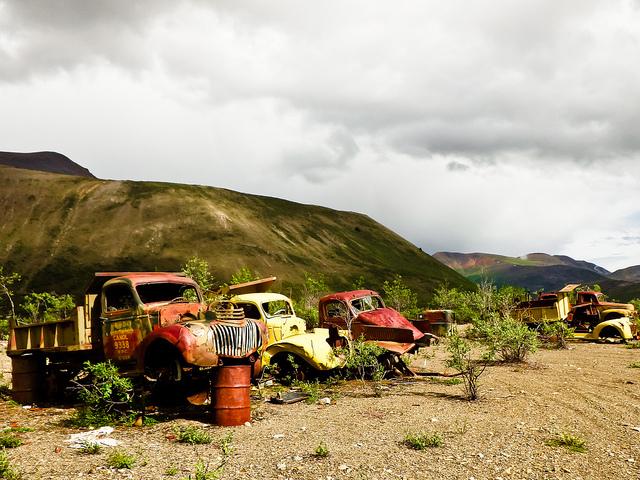Have these cars been trashed?
Give a very brief answer. Yes. What color is the barrel?
Keep it brief. Red. Could you drive any of these cars?
Short answer required. No. 